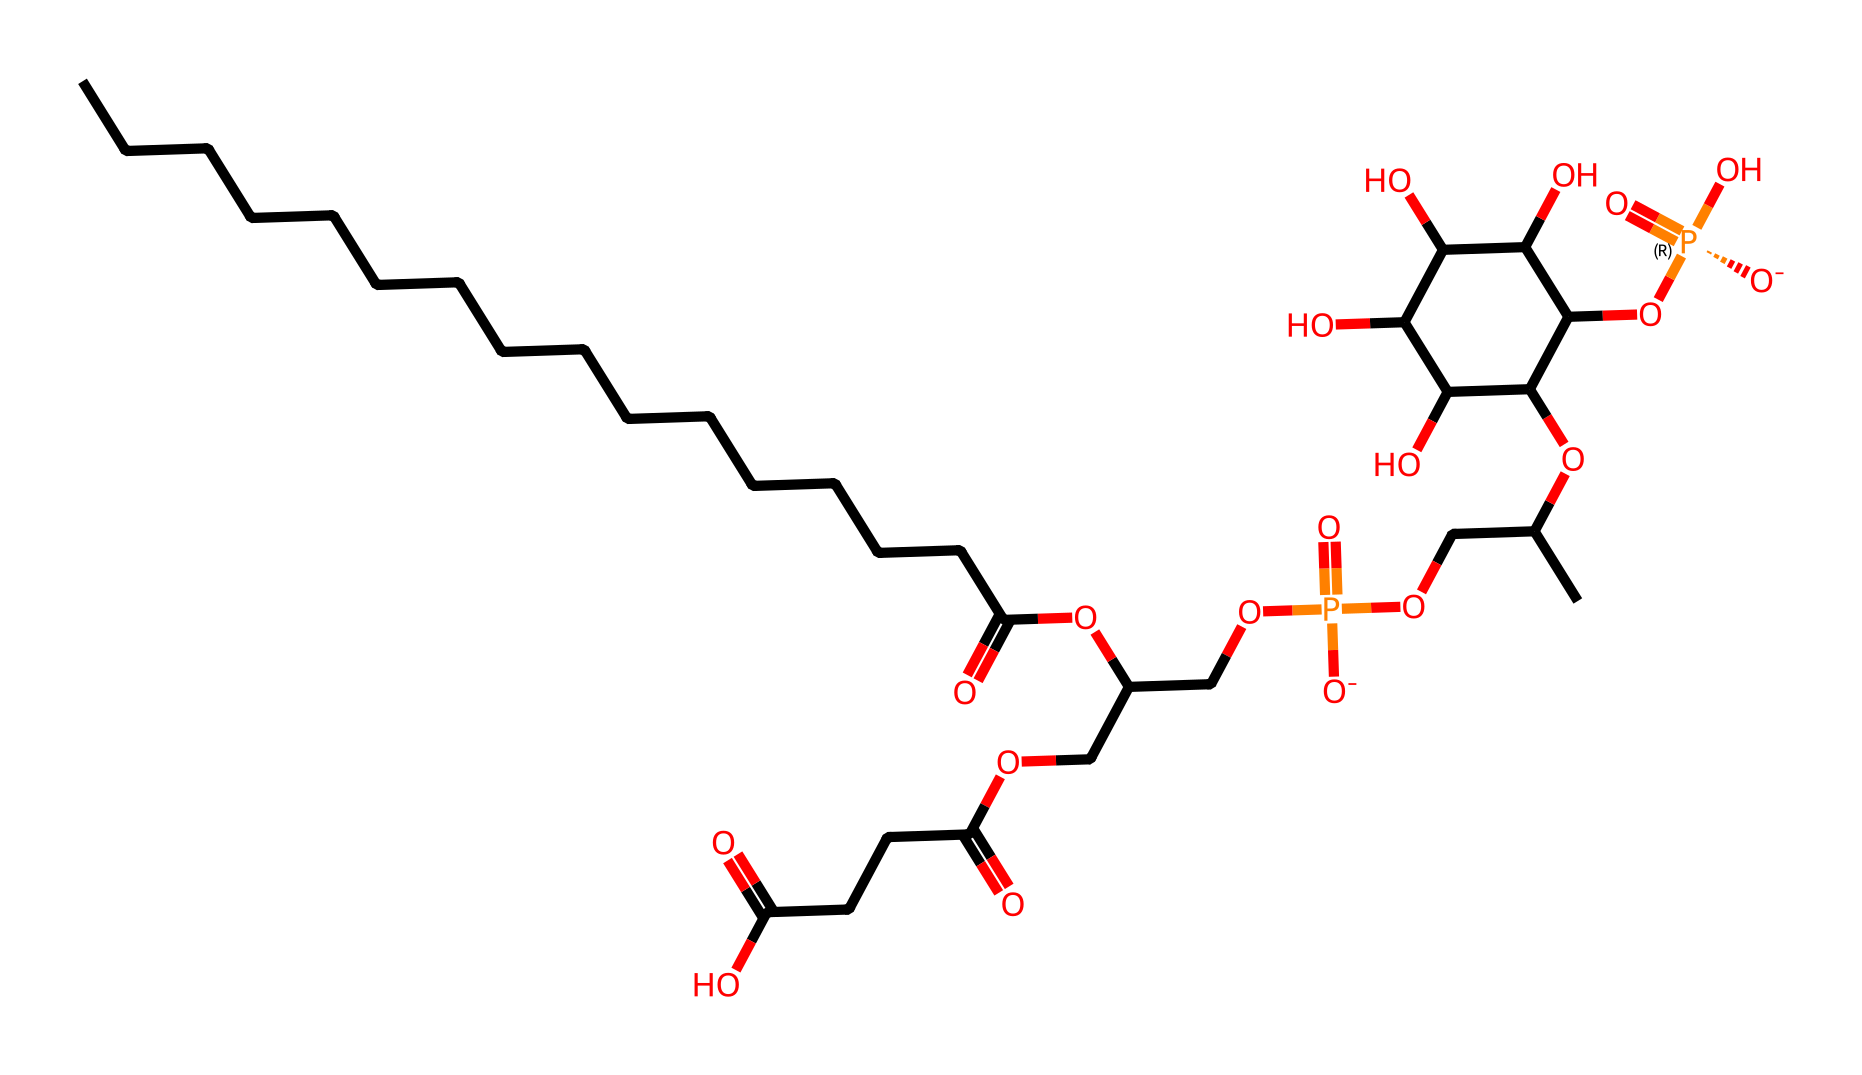What is the primary functional group present in phosphatidylinositol? The compound contains a phosphate group (P=O) that is characteristic of lipids and signaling molecules like phosphatidylinositol.
Answer: phosphate How many carbon atoms are present in this molecule? By counting the carbon (C) atoms in the SMILES representation, there are 25 carbon atoms in total, which can be verified by carefully parsing the representation.
Answer: 25 What is the role of phosphatidylinositol in neural pathways? Phosphatidylinositol acts as a signaling molecule, crucial in generating inositol trisphosphate and diacylglycerol, which are involved in cellular signaling pathways impacting memory and identity.
Answer: signaling molecule How many hydroxyl (−OH) groups are present in this molecule? The representation includes multiple occurrences of -OH groups, totaling 8 hydroxyl groups in the chemical structure, which correspond to specific parts of the molecule that impact its properties.
Answer: 8 What ionization state does the phosphate group in phosphatidylinositol typically exhibit? The phosphate group in the chemical structure is negatively charged, as indicated by the presence of [O-] in the SMILES, which denotes deprotonation and thus reflects its ionization state.
Answer: negatively charged Which type of compound does phosphatidylinositol belong to? Based on the presence of fatty acid chains and a phosphate group, phosphatidylinositol belongs to the category of phospholipids, important in cell membrane structure and function.
Answer: phospholipid 